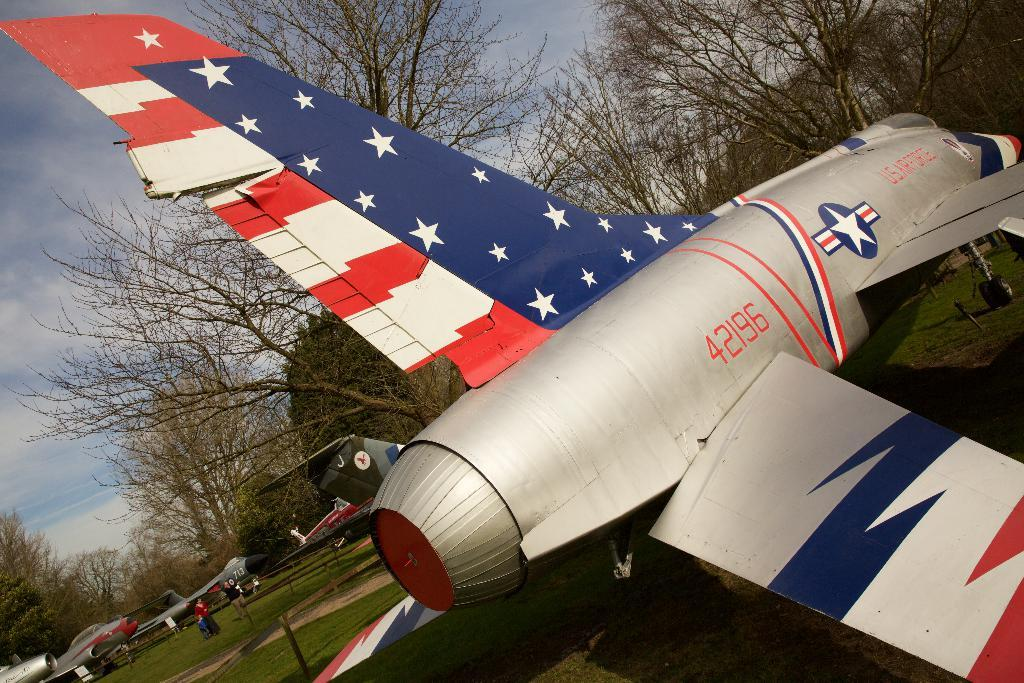What type of vehicles are in the grass in the image? There are planes in the grass in the image. What can be seen in the background of the image? Trees are visible around the planes in the image. Are there any people present in the image? Yes, there are people standing nearby in the image. Where is the harbor located in the image? There is no harbor present in the image; it features planes in the grass with trees in the background and people nearby. How many kittens can be seen playing on the line in the image? There are no kittens or lines present in the image. 